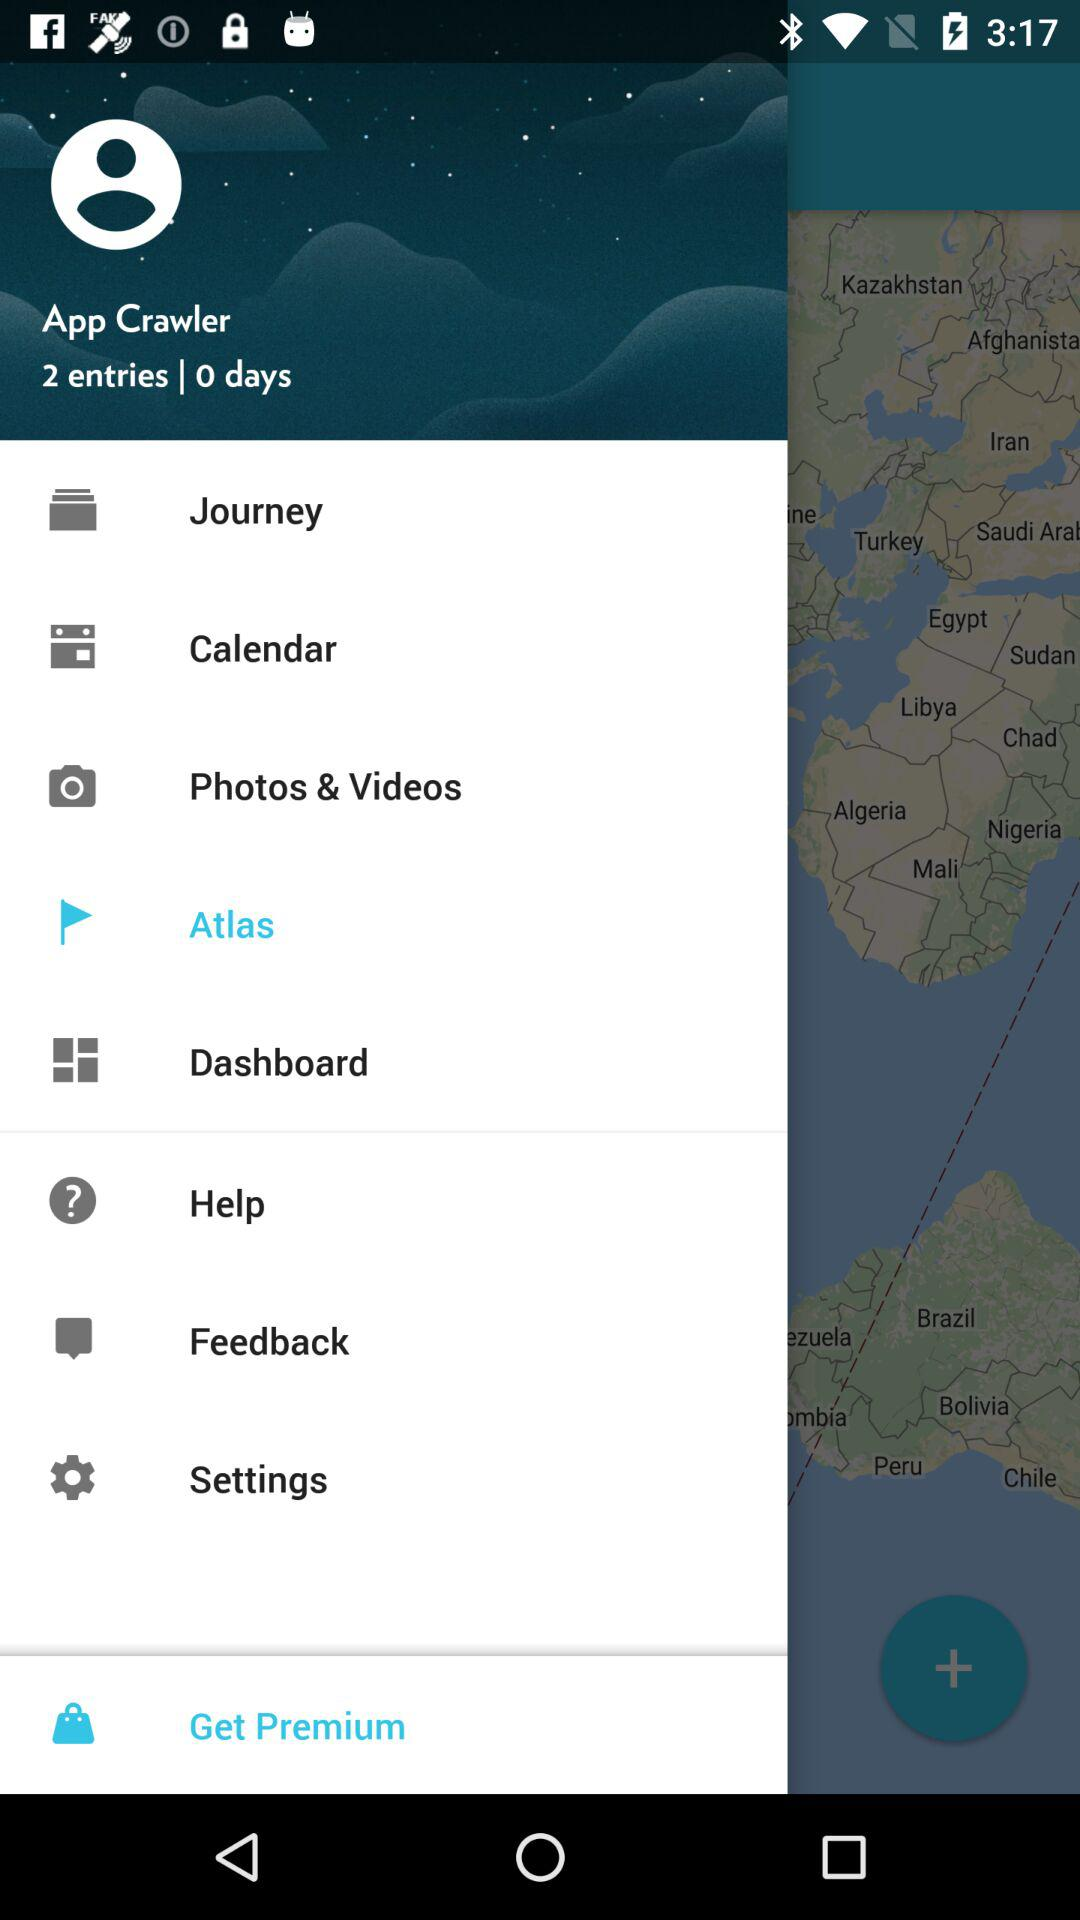How many entries are there? There are 2 entries. 